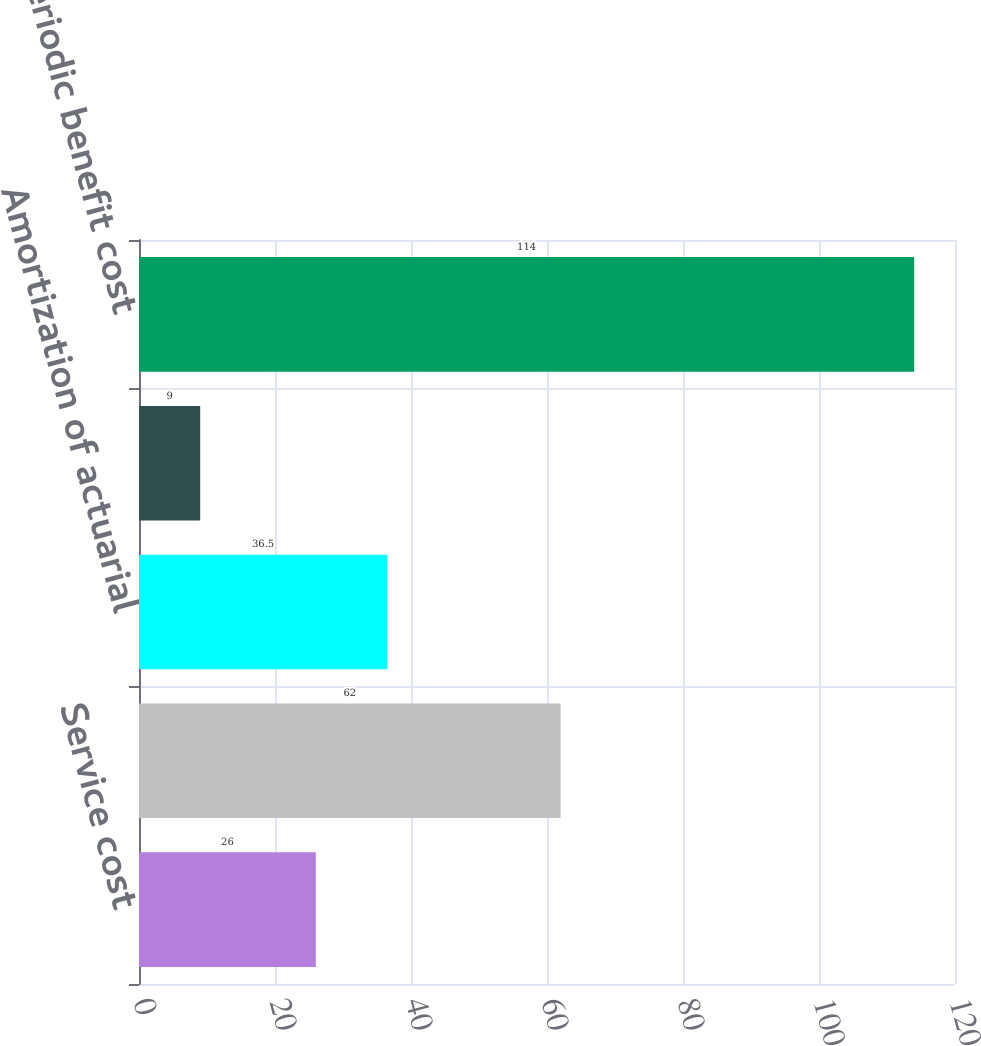<chart> <loc_0><loc_0><loc_500><loc_500><bar_chart><fcel>Service cost<fcel>Interest cost<fcel>Amortization of actuarial<fcel>loss Amortization of<fcel>Net periodic benefit cost<nl><fcel>26<fcel>62<fcel>36.5<fcel>9<fcel>114<nl></chart> 